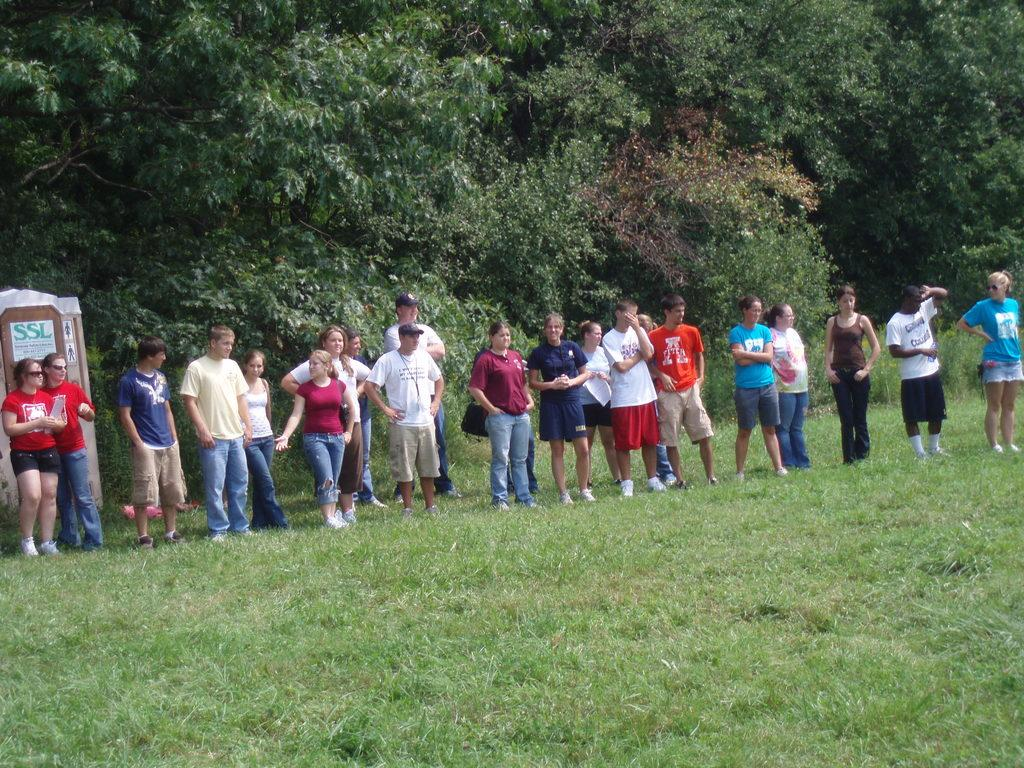What is the main subject of the image? The main subject of the image is a group of people standing on the ground. What can be seen on the left side of the image? There is an object on the left side of the image. What type of natural environment is visible in the background? There are trees and grass visible in the background of the image. What time of day is it in the image, given the presence of fire? There is no fire present in the image, so it cannot be determined from the image what time of day it is. 